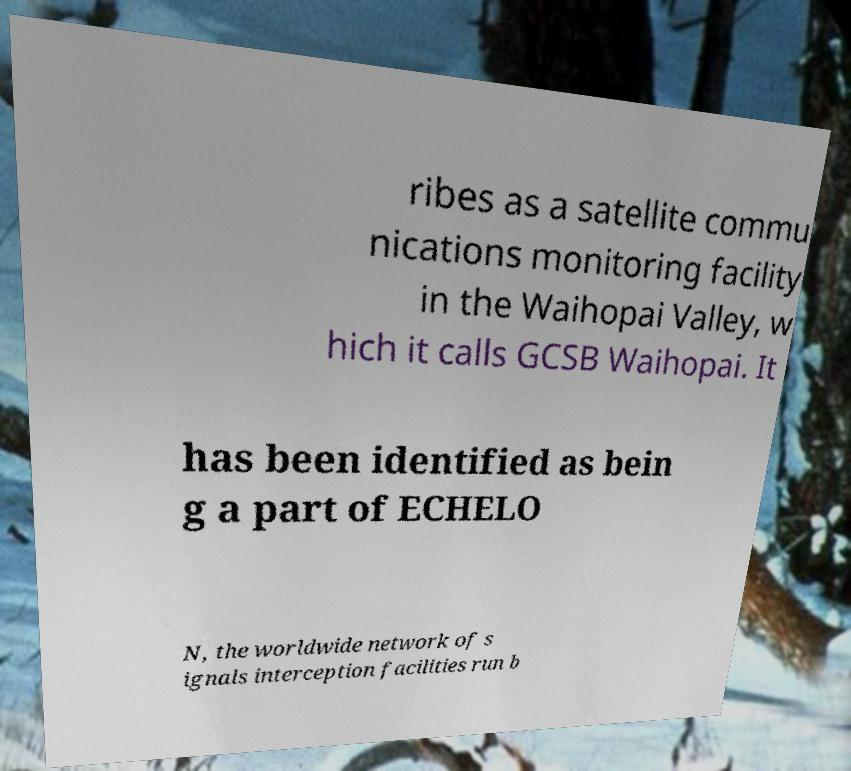There's text embedded in this image that I need extracted. Can you transcribe it verbatim? ribes as a satellite commu nications monitoring facility in the Waihopai Valley, w hich it calls GCSB Waihopai. It has been identified as bein g a part of ECHELO N, the worldwide network of s ignals interception facilities run b 